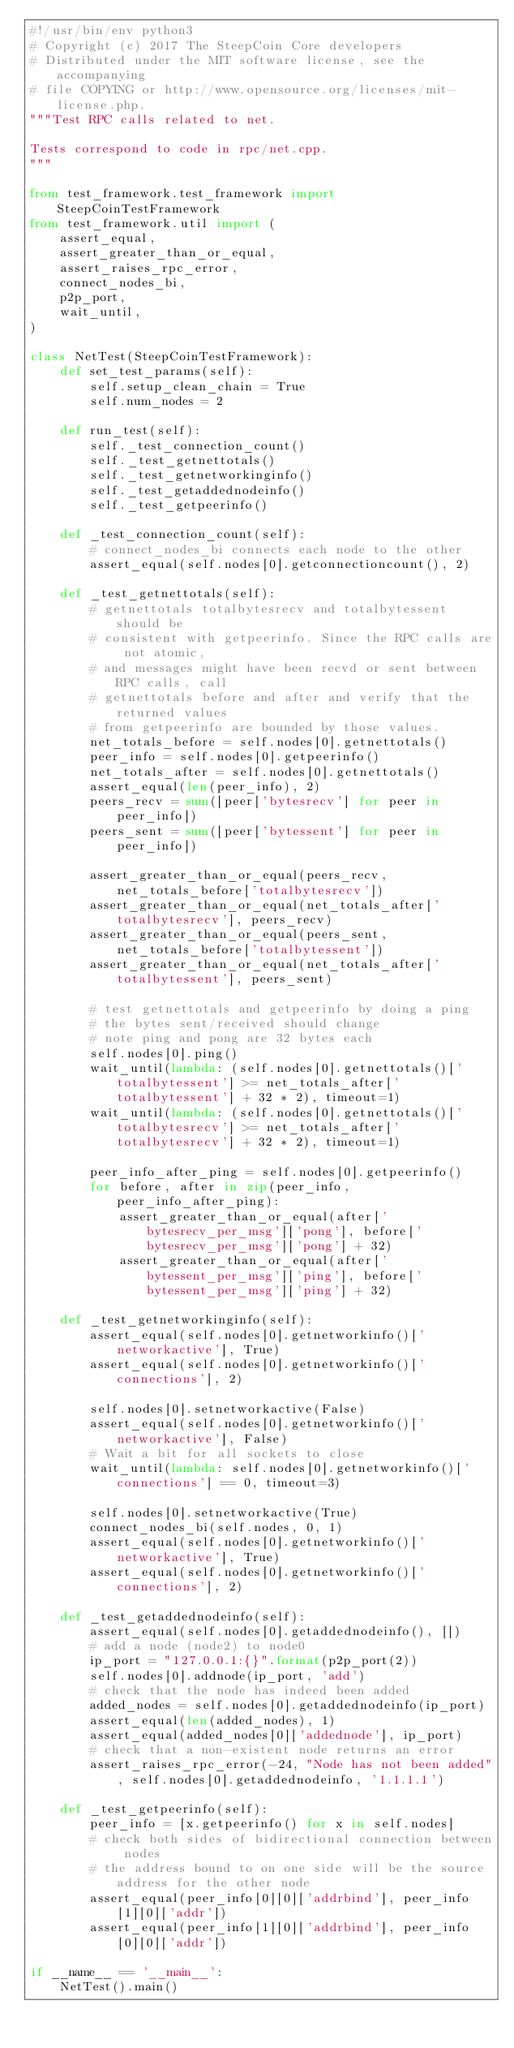<code> <loc_0><loc_0><loc_500><loc_500><_Python_>#!/usr/bin/env python3
# Copyright (c) 2017 The SteepCoin Core developers
# Distributed under the MIT software license, see the accompanying
# file COPYING or http://www.opensource.org/licenses/mit-license.php.
"""Test RPC calls related to net.

Tests correspond to code in rpc/net.cpp.
"""

from test_framework.test_framework import SteepCoinTestFramework
from test_framework.util import (
    assert_equal,
    assert_greater_than_or_equal,
    assert_raises_rpc_error,
    connect_nodes_bi,
    p2p_port,
    wait_until,
)

class NetTest(SteepCoinTestFramework):
    def set_test_params(self):
        self.setup_clean_chain = True
        self.num_nodes = 2

    def run_test(self):
        self._test_connection_count()
        self._test_getnettotals()
        self._test_getnetworkinginfo()
        self._test_getaddednodeinfo()
        self._test_getpeerinfo()

    def _test_connection_count(self):
        # connect_nodes_bi connects each node to the other
        assert_equal(self.nodes[0].getconnectioncount(), 2)

    def _test_getnettotals(self):
        # getnettotals totalbytesrecv and totalbytessent should be
        # consistent with getpeerinfo. Since the RPC calls are not atomic,
        # and messages might have been recvd or sent between RPC calls, call
        # getnettotals before and after and verify that the returned values
        # from getpeerinfo are bounded by those values.
        net_totals_before = self.nodes[0].getnettotals()
        peer_info = self.nodes[0].getpeerinfo()
        net_totals_after = self.nodes[0].getnettotals()
        assert_equal(len(peer_info), 2)
        peers_recv = sum([peer['bytesrecv'] for peer in peer_info])
        peers_sent = sum([peer['bytessent'] for peer in peer_info])

        assert_greater_than_or_equal(peers_recv, net_totals_before['totalbytesrecv'])
        assert_greater_than_or_equal(net_totals_after['totalbytesrecv'], peers_recv)
        assert_greater_than_or_equal(peers_sent, net_totals_before['totalbytessent'])
        assert_greater_than_or_equal(net_totals_after['totalbytessent'], peers_sent)

        # test getnettotals and getpeerinfo by doing a ping
        # the bytes sent/received should change
        # note ping and pong are 32 bytes each
        self.nodes[0].ping()
        wait_until(lambda: (self.nodes[0].getnettotals()['totalbytessent'] >= net_totals_after['totalbytessent'] + 32 * 2), timeout=1)
        wait_until(lambda: (self.nodes[0].getnettotals()['totalbytesrecv'] >= net_totals_after['totalbytesrecv'] + 32 * 2), timeout=1)

        peer_info_after_ping = self.nodes[0].getpeerinfo()
        for before, after in zip(peer_info, peer_info_after_ping):
            assert_greater_than_or_equal(after['bytesrecv_per_msg']['pong'], before['bytesrecv_per_msg']['pong'] + 32)
            assert_greater_than_or_equal(after['bytessent_per_msg']['ping'], before['bytessent_per_msg']['ping'] + 32)

    def _test_getnetworkinginfo(self):
        assert_equal(self.nodes[0].getnetworkinfo()['networkactive'], True)
        assert_equal(self.nodes[0].getnetworkinfo()['connections'], 2)

        self.nodes[0].setnetworkactive(False)
        assert_equal(self.nodes[0].getnetworkinfo()['networkactive'], False)
        # Wait a bit for all sockets to close
        wait_until(lambda: self.nodes[0].getnetworkinfo()['connections'] == 0, timeout=3)

        self.nodes[0].setnetworkactive(True)
        connect_nodes_bi(self.nodes, 0, 1)
        assert_equal(self.nodes[0].getnetworkinfo()['networkactive'], True)
        assert_equal(self.nodes[0].getnetworkinfo()['connections'], 2)

    def _test_getaddednodeinfo(self):
        assert_equal(self.nodes[0].getaddednodeinfo(), [])
        # add a node (node2) to node0
        ip_port = "127.0.0.1:{}".format(p2p_port(2))
        self.nodes[0].addnode(ip_port, 'add')
        # check that the node has indeed been added
        added_nodes = self.nodes[0].getaddednodeinfo(ip_port)
        assert_equal(len(added_nodes), 1)
        assert_equal(added_nodes[0]['addednode'], ip_port)
        # check that a non-existent node returns an error
        assert_raises_rpc_error(-24, "Node has not been added", self.nodes[0].getaddednodeinfo, '1.1.1.1')

    def _test_getpeerinfo(self):
        peer_info = [x.getpeerinfo() for x in self.nodes]
        # check both sides of bidirectional connection between nodes
        # the address bound to on one side will be the source address for the other node
        assert_equal(peer_info[0][0]['addrbind'], peer_info[1][0]['addr'])
        assert_equal(peer_info[1][0]['addrbind'], peer_info[0][0]['addr'])

if __name__ == '__main__':
    NetTest().main()
</code> 